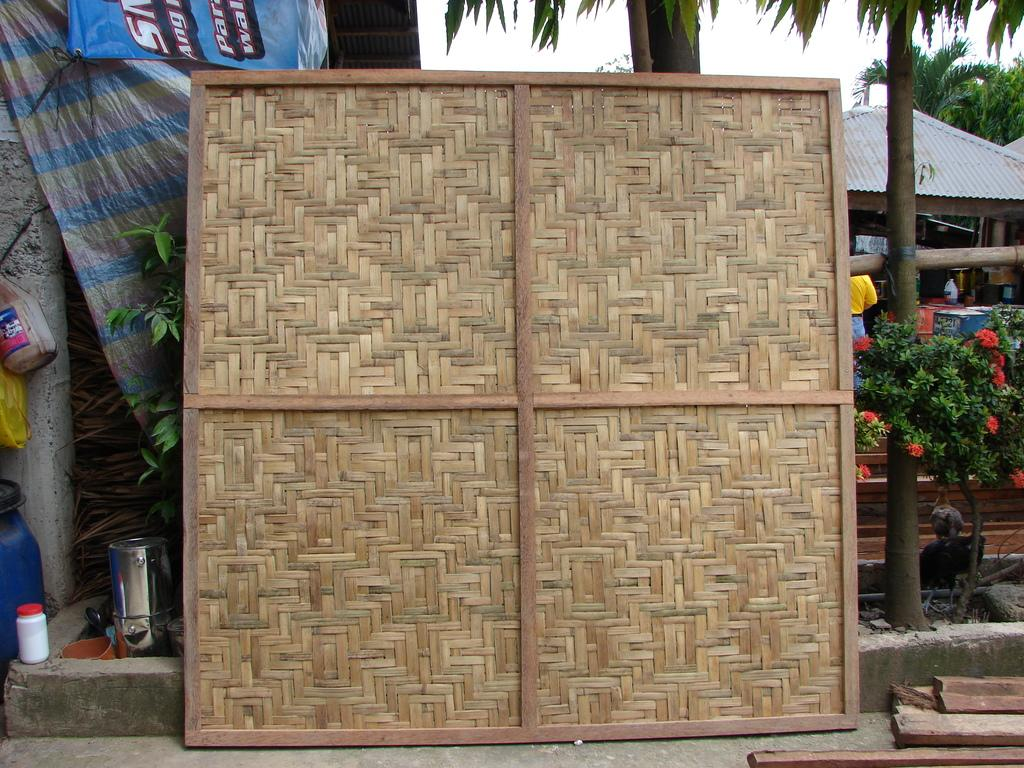What type of material is the wooden object made of in the image? The wooden object in the image is made of wood. What can be seen on the left side of the image? There are objects on the left side of the image. What type of vegetation is on the right side of the image? There is a plant on the right side of the image. What is visible in the background of the image? There is a house and trees in the background of the image. What rhythm is the police officer following in the image? There is no police officer present in the image, and therefore no rhythm can be observed. What process is being carried out by the objects on the left side of the image? The provided facts do not mention any process being carried out by the objects on the left side of the image. 